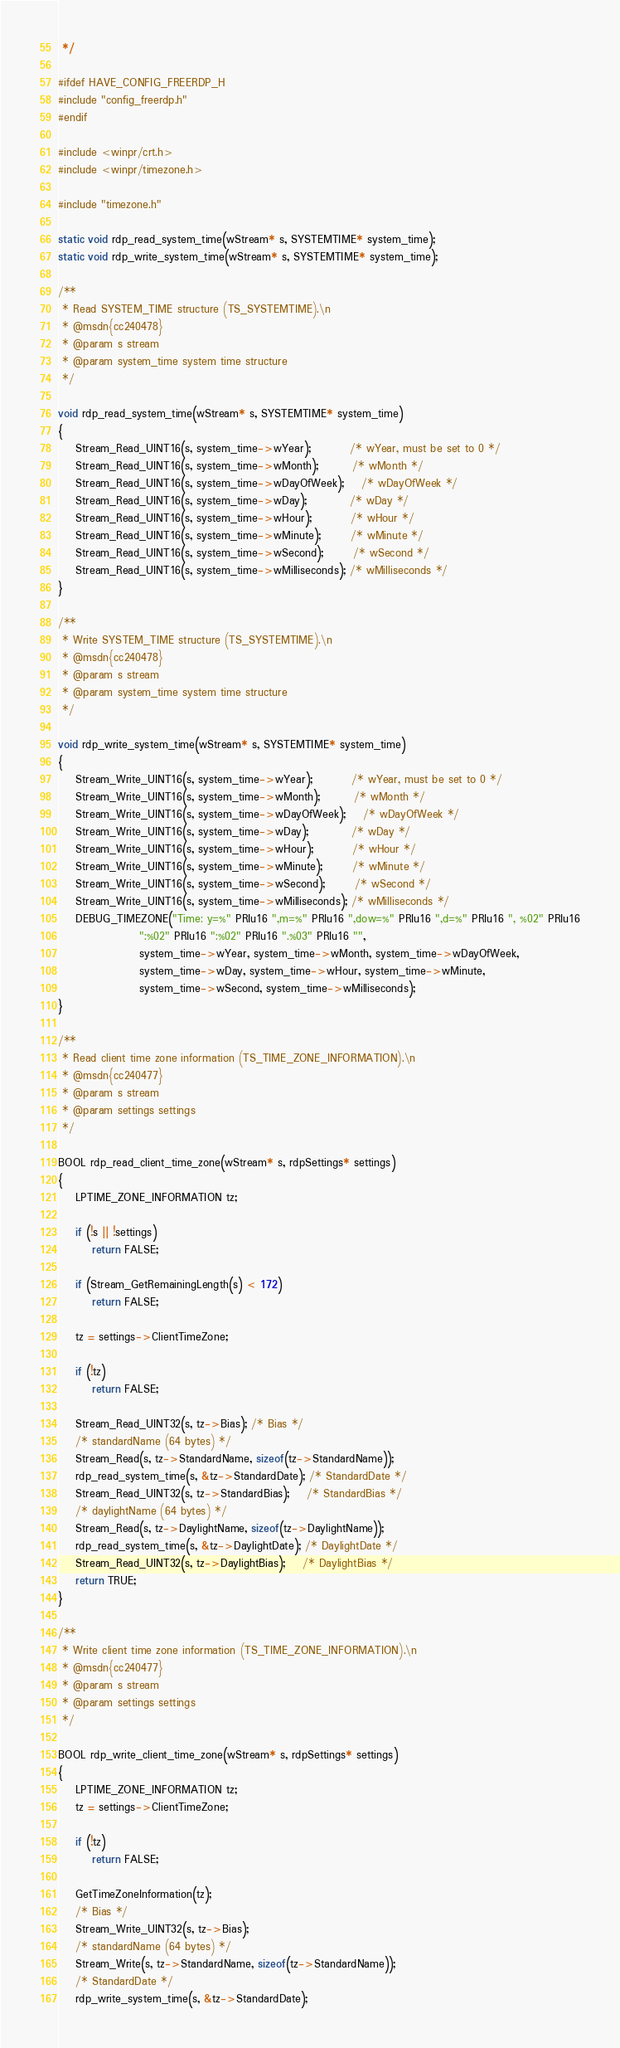Convert code to text. <code><loc_0><loc_0><loc_500><loc_500><_C_> */

#ifdef HAVE_CONFIG_FREERDP_H
#include "config_freerdp.h"
#endif

#include <winpr/crt.h>
#include <winpr/timezone.h>

#include "timezone.h"

static void rdp_read_system_time(wStream* s, SYSTEMTIME* system_time);
static void rdp_write_system_time(wStream* s, SYSTEMTIME* system_time);

/**
 * Read SYSTEM_TIME structure (TS_SYSTEMTIME).\n
 * @msdn{cc240478}
 * @param s stream
 * @param system_time system time structure
 */

void rdp_read_system_time(wStream* s, SYSTEMTIME* system_time)
{
	Stream_Read_UINT16(s, system_time->wYear);         /* wYear, must be set to 0 */
	Stream_Read_UINT16(s, system_time->wMonth);        /* wMonth */
	Stream_Read_UINT16(s, system_time->wDayOfWeek);    /* wDayOfWeek */
	Stream_Read_UINT16(s, system_time->wDay);          /* wDay */
	Stream_Read_UINT16(s, system_time->wHour);         /* wHour */
	Stream_Read_UINT16(s, system_time->wMinute);       /* wMinute */
	Stream_Read_UINT16(s, system_time->wSecond);       /* wSecond */
	Stream_Read_UINT16(s, system_time->wMilliseconds); /* wMilliseconds */
}

/**
 * Write SYSTEM_TIME structure (TS_SYSTEMTIME).\n
 * @msdn{cc240478}
 * @param s stream
 * @param system_time system time structure
 */

void rdp_write_system_time(wStream* s, SYSTEMTIME* system_time)
{
	Stream_Write_UINT16(s, system_time->wYear);         /* wYear, must be set to 0 */
	Stream_Write_UINT16(s, system_time->wMonth);        /* wMonth */
	Stream_Write_UINT16(s, system_time->wDayOfWeek);    /* wDayOfWeek */
	Stream_Write_UINT16(s, system_time->wDay);          /* wDay */
	Stream_Write_UINT16(s, system_time->wHour);         /* wHour */
	Stream_Write_UINT16(s, system_time->wMinute);       /* wMinute */
	Stream_Write_UINT16(s, system_time->wSecond);       /* wSecond */
	Stream_Write_UINT16(s, system_time->wMilliseconds); /* wMilliseconds */
	DEBUG_TIMEZONE("Time: y=%" PRIu16 ",m=%" PRIu16 ",dow=%" PRIu16 ",d=%" PRIu16 ", %02" PRIu16
	               ":%02" PRIu16 ":%02" PRIu16 ".%03" PRIu16 "",
	               system_time->wYear, system_time->wMonth, system_time->wDayOfWeek,
	               system_time->wDay, system_time->wHour, system_time->wMinute,
	               system_time->wSecond, system_time->wMilliseconds);
}

/**
 * Read client time zone information (TS_TIME_ZONE_INFORMATION).\n
 * @msdn{cc240477}
 * @param s stream
 * @param settings settings
 */

BOOL rdp_read_client_time_zone(wStream* s, rdpSettings* settings)
{
	LPTIME_ZONE_INFORMATION tz;

	if (!s || !settings)
		return FALSE;

	if (Stream_GetRemainingLength(s) < 172)
		return FALSE;

	tz = settings->ClientTimeZone;

	if (!tz)
		return FALSE;

	Stream_Read_UINT32(s, tz->Bias); /* Bias */
	/* standardName (64 bytes) */
	Stream_Read(s, tz->StandardName, sizeof(tz->StandardName));
	rdp_read_system_time(s, &tz->StandardDate); /* StandardDate */
	Stream_Read_UINT32(s, tz->StandardBias);    /* StandardBias */
	/* daylightName (64 bytes) */
	Stream_Read(s, tz->DaylightName, sizeof(tz->DaylightName));
	rdp_read_system_time(s, &tz->DaylightDate); /* DaylightDate */
	Stream_Read_UINT32(s, tz->DaylightBias);    /* DaylightBias */
	return TRUE;
}

/**
 * Write client time zone information (TS_TIME_ZONE_INFORMATION).\n
 * @msdn{cc240477}
 * @param s stream
 * @param settings settings
 */

BOOL rdp_write_client_time_zone(wStream* s, rdpSettings* settings)
{
	LPTIME_ZONE_INFORMATION tz;
	tz = settings->ClientTimeZone;

	if (!tz)
		return FALSE;

	GetTimeZoneInformation(tz);
	/* Bias */
	Stream_Write_UINT32(s, tz->Bias);
	/* standardName (64 bytes) */
	Stream_Write(s, tz->StandardName, sizeof(tz->StandardName));
	/* StandardDate */
	rdp_write_system_time(s, &tz->StandardDate);</code> 